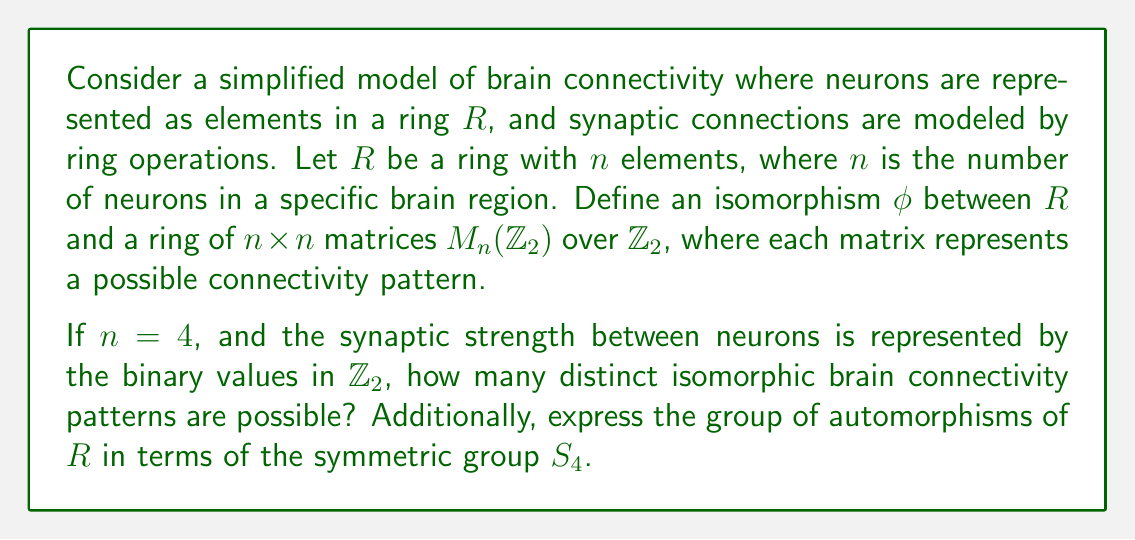Can you solve this math problem? To solve this problem, we need to follow these steps:

1) First, we need to understand what the isomorphism $\phi$ represents. It maps each element of $R$ to a $4 \times 4$ matrix over $\mathbb{Z}_2$, preserving the ring structure.

2) The number of distinct $4 \times 4$ matrices over $\mathbb{Z}_2$ is $2^{16} = 65536$, as each of the 16 entries can be either 0 or 1.

3) However, not all of these matrices will form a ring isomorphic to $R$. The number of distinct isomorphic rings will be equal to the number of non-isomorphic rings with 4 elements.

4) There are 11 non-isomorphic rings with 4 elements:
   - $\mathbb{Z}_4$
   - $\mathbb{Z}_2[x]/(x^2)$
   - $\mathbb{Z}_2 \times \mathbb{Z}_2$
   - $\mathbb{F}_4$ (the field with 4 elements)
   - Seven zero rings (rings where all products are zero) with different additive structures

5) Therefore, there are 11 distinct isomorphic brain connectivity patterns possible.

6) For the second part of the question, we need to consider the automorphism group of $R$. An automorphism of a ring is an isomorphism from the ring to itself.

7) The automorphism group of a ring with 4 elements depends on its specific structure. However, we can express it in terms of $S_4$ (the symmetric group on 4 elements) for each case:

   - For $\mathbb{Z}_4$, the automorphism group is isomorphic to $\mathbb{Z}_2$, a subgroup of $S_4$.
   - For $\mathbb{Z}_2[x]/(x^2)$, the automorphism group is also isomorphic to $\mathbb{Z}_2$.
   - For $\mathbb{Z}_2 \times \mathbb{Z}_2$, the automorphism group is isomorphic to $S_3$, a subgroup of $S_4$.
   - For $\mathbb{F}_4$, the automorphism group is isomorphic to $\mathbb{Z}_2$.
   - For the zero rings, the automorphism group is the full symmetric group $S_4$.

8) Therefore, the automorphism group of $R$ is a subgroup of $S_4$, with the specific subgroup depending on the structure of $R$.
Answer: There are 11 distinct isomorphic brain connectivity patterns possible. The automorphism group of $R$ is a subgroup of $S_4$, with the specific subgroup depending on the structure of $R$. It can be $\mathbb{Z}_2$, $S_3$, or $S_4$. 